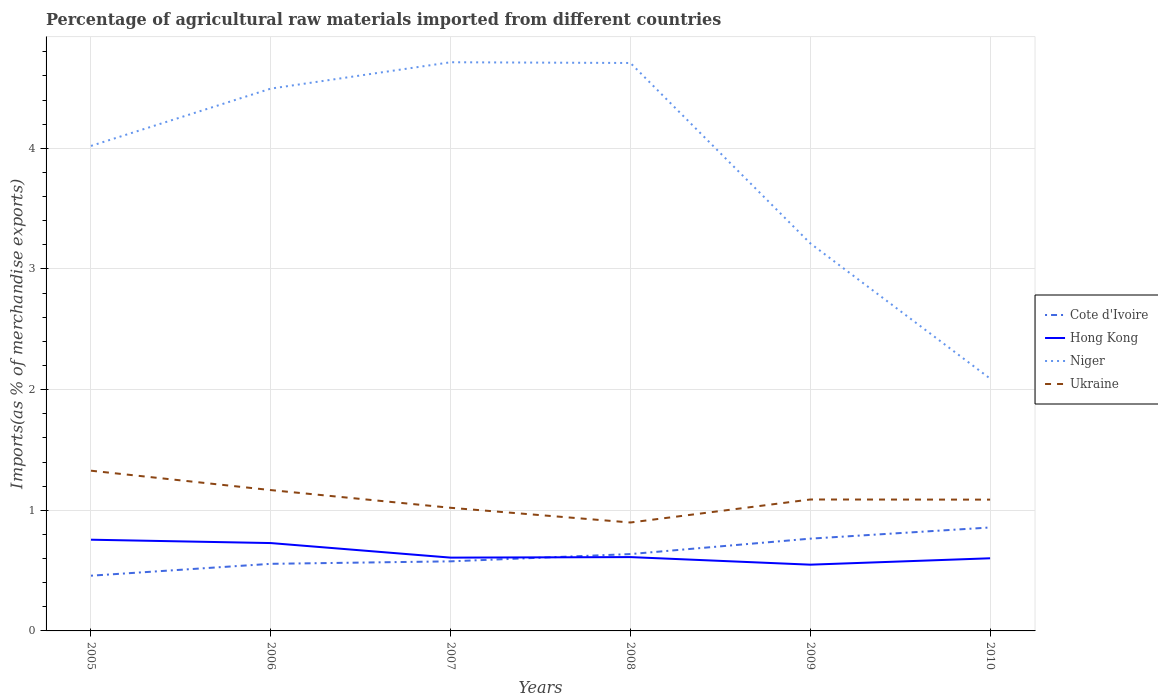Across all years, what is the maximum percentage of imports to different countries in Hong Kong?
Provide a succinct answer. 0.55. What is the total percentage of imports to different countries in Niger in the graph?
Provide a succinct answer. 1.5. What is the difference between the highest and the second highest percentage of imports to different countries in Niger?
Keep it short and to the point. 2.62. What is the difference between the highest and the lowest percentage of imports to different countries in Hong Kong?
Offer a terse response. 2. Is the percentage of imports to different countries in Niger strictly greater than the percentage of imports to different countries in Cote d'Ivoire over the years?
Your answer should be compact. No. How many lines are there?
Give a very brief answer. 4. Does the graph contain any zero values?
Provide a succinct answer. No. Does the graph contain grids?
Make the answer very short. Yes. How many legend labels are there?
Offer a terse response. 4. What is the title of the graph?
Ensure brevity in your answer.  Percentage of agricultural raw materials imported from different countries. Does "Haiti" appear as one of the legend labels in the graph?
Ensure brevity in your answer.  No. What is the label or title of the X-axis?
Your answer should be compact. Years. What is the label or title of the Y-axis?
Your answer should be compact. Imports(as % of merchandise exports). What is the Imports(as % of merchandise exports) of Cote d'Ivoire in 2005?
Offer a terse response. 0.46. What is the Imports(as % of merchandise exports) in Hong Kong in 2005?
Your answer should be compact. 0.76. What is the Imports(as % of merchandise exports) in Niger in 2005?
Your answer should be very brief. 4.02. What is the Imports(as % of merchandise exports) of Ukraine in 2005?
Offer a terse response. 1.33. What is the Imports(as % of merchandise exports) of Cote d'Ivoire in 2006?
Provide a short and direct response. 0.56. What is the Imports(as % of merchandise exports) of Hong Kong in 2006?
Provide a succinct answer. 0.73. What is the Imports(as % of merchandise exports) of Niger in 2006?
Keep it short and to the point. 4.49. What is the Imports(as % of merchandise exports) of Ukraine in 2006?
Offer a terse response. 1.17. What is the Imports(as % of merchandise exports) in Cote d'Ivoire in 2007?
Your answer should be very brief. 0.58. What is the Imports(as % of merchandise exports) in Hong Kong in 2007?
Your answer should be very brief. 0.61. What is the Imports(as % of merchandise exports) in Niger in 2007?
Make the answer very short. 4.71. What is the Imports(as % of merchandise exports) in Ukraine in 2007?
Offer a terse response. 1.02. What is the Imports(as % of merchandise exports) in Cote d'Ivoire in 2008?
Your answer should be compact. 0.64. What is the Imports(as % of merchandise exports) in Hong Kong in 2008?
Ensure brevity in your answer.  0.61. What is the Imports(as % of merchandise exports) of Niger in 2008?
Keep it short and to the point. 4.71. What is the Imports(as % of merchandise exports) of Ukraine in 2008?
Your response must be concise. 0.9. What is the Imports(as % of merchandise exports) of Cote d'Ivoire in 2009?
Your answer should be compact. 0.76. What is the Imports(as % of merchandise exports) of Hong Kong in 2009?
Ensure brevity in your answer.  0.55. What is the Imports(as % of merchandise exports) of Niger in 2009?
Keep it short and to the point. 3.21. What is the Imports(as % of merchandise exports) in Ukraine in 2009?
Your response must be concise. 1.09. What is the Imports(as % of merchandise exports) in Cote d'Ivoire in 2010?
Offer a very short reply. 0.86. What is the Imports(as % of merchandise exports) in Hong Kong in 2010?
Your response must be concise. 0.6. What is the Imports(as % of merchandise exports) of Niger in 2010?
Provide a succinct answer. 2.09. What is the Imports(as % of merchandise exports) in Ukraine in 2010?
Make the answer very short. 1.09. Across all years, what is the maximum Imports(as % of merchandise exports) of Cote d'Ivoire?
Ensure brevity in your answer.  0.86. Across all years, what is the maximum Imports(as % of merchandise exports) of Hong Kong?
Your answer should be compact. 0.76. Across all years, what is the maximum Imports(as % of merchandise exports) of Niger?
Ensure brevity in your answer.  4.71. Across all years, what is the maximum Imports(as % of merchandise exports) of Ukraine?
Provide a succinct answer. 1.33. Across all years, what is the minimum Imports(as % of merchandise exports) of Cote d'Ivoire?
Your answer should be very brief. 0.46. Across all years, what is the minimum Imports(as % of merchandise exports) of Hong Kong?
Keep it short and to the point. 0.55. Across all years, what is the minimum Imports(as % of merchandise exports) in Niger?
Offer a terse response. 2.09. Across all years, what is the minimum Imports(as % of merchandise exports) of Ukraine?
Provide a short and direct response. 0.9. What is the total Imports(as % of merchandise exports) in Cote d'Ivoire in the graph?
Make the answer very short. 3.85. What is the total Imports(as % of merchandise exports) in Hong Kong in the graph?
Keep it short and to the point. 3.85. What is the total Imports(as % of merchandise exports) of Niger in the graph?
Offer a very short reply. 23.24. What is the total Imports(as % of merchandise exports) in Ukraine in the graph?
Your answer should be very brief. 6.59. What is the difference between the Imports(as % of merchandise exports) in Cote d'Ivoire in 2005 and that in 2006?
Your answer should be very brief. -0.1. What is the difference between the Imports(as % of merchandise exports) of Hong Kong in 2005 and that in 2006?
Offer a very short reply. 0.03. What is the difference between the Imports(as % of merchandise exports) of Niger in 2005 and that in 2006?
Your answer should be compact. -0.47. What is the difference between the Imports(as % of merchandise exports) of Ukraine in 2005 and that in 2006?
Your answer should be compact. 0.16. What is the difference between the Imports(as % of merchandise exports) in Cote d'Ivoire in 2005 and that in 2007?
Make the answer very short. -0.12. What is the difference between the Imports(as % of merchandise exports) in Hong Kong in 2005 and that in 2007?
Your answer should be very brief. 0.15. What is the difference between the Imports(as % of merchandise exports) of Niger in 2005 and that in 2007?
Ensure brevity in your answer.  -0.69. What is the difference between the Imports(as % of merchandise exports) of Ukraine in 2005 and that in 2007?
Your answer should be very brief. 0.31. What is the difference between the Imports(as % of merchandise exports) in Cote d'Ivoire in 2005 and that in 2008?
Provide a succinct answer. -0.18. What is the difference between the Imports(as % of merchandise exports) of Hong Kong in 2005 and that in 2008?
Your response must be concise. 0.14. What is the difference between the Imports(as % of merchandise exports) in Niger in 2005 and that in 2008?
Ensure brevity in your answer.  -0.69. What is the difference between the Imports(as % of merchandise exports) in Ukraine in 2005 and that in 2008?
Keep it short and to the point. 0.43. What is the difference between the Imports(as % of merchandise exports) of Cote d'Ivoire in 2005 and that in 2009?
Give a very brief answer. -0.31. What is the difference between the Imports(as % of merchandise exports) in Hong Kong in 2005 and that in 2009?
Make the answer very short. 0.21. What is the difference between the Imports(as % of merchandise exports) of Niger in 2005 and that in 2009?
Ensure brevity in your answer.  0.81. What is the difference between the Imports(as % of merchandise exports) in Ukraine in 2005 and that in 2009?
Offer a terse response. 0.24. What is the difference between the Imports(as % of merchandise exports) of Cote d'Ivoire in 2005 and that in 2010?
Provide a succinct answer. -0.4. What is the difference between the Imports(as % of merchandise exports) in Hong Kong in 2005 and that in 2010?
Ensure brevity in your answer.  0.15. What is the difference between the Imports(as % of merchandise exports) in Niger in 2005 and that in 2010?
Keep it short and to the point. 1.93. What is the difference between the Imports(as % of merchandise exports) in Ukraine in 2005 and that in 2010?
Give a very brief answer. 0.24. What is the difference between the Imports(as % of merchandise exports) in Cote d'Ivoire in 2006 and that in 2007?
Give a very brief answer. -0.02. What is the difference between the Imports(as % of merchandise exports) of Hong Kong in 2006 and that in 2007?
Offer a terse response. 0.12. What is the difference between the Imports(as % of merchandise exports) in Niger in 2006 and that in 2007?
Ensure brevity in your answer.  -0.22. What is the difference between the Imports(as % of merchandise exports) of Ukraine in 2006 and that in 2007?
Your response must be concise. 0.15. What is the difference between the Imports(as % of merchandise exports) of Cote d'Ivoire in 2006 and that in 2008?
Offer a very short reply. -0.08. What is the difference between the Imports(as % of merchandise exports) in Hong Kong in 2006 and that in 2008?
Provide a succinct answer. 0.12. What is the difference between the Imports(as % of merchandise exports) of Niger in 2006 and that in 2008?
Offer a very short reply. -0.21. What is the difference between the Imports(as % of merchandise exports) of Ukraine in 2006 and that in 2008?
Your answer should be compact. 0.27. What is the difference between the Imports(as % of merchandise exports) of Cote d'Ivoire in 2006 and that in 2009?
Make the answer very short. -0.21. What is the difference between the Imports(as % of merchandise exports) of Hong Kong in 2006 and that in 2009?
Keep it short and to the point. 0.18. What is the difference between the Imports(as % of merchandise exports) in Niger in 2006 and that in 2009?
Offer a terse response. 1.28. What is the difference between the Imports(as % of merchandise exports) in Ukraine in 2006 and that in 2009?
Keep it short and to the point. 0.08. What is the difference between the Imports(as % of merchandise exports) of Cote d'Ivoire in 2006 and that in 2010?
Your response must be concise. -0.3. What is the difference between the Imports(as % of merchandise exports) of Hong Kong in 2006 and that in 2010?
Make the answer very short. 0.13. What is the difference between the Imports(as % of merchandise exports) of Niger in 2006 and that in 2010?
Your answer should be very brief. 2.4. What is the difference between the Imports(as % of merchandise exports) in Ukraine in 2006 and that in 2010?
Make the answer very short. 0.08. What is the difference between the Imports(as % of merchandise exports) in Cote d'Ivoire in 2007 and that in 2008?
Your response must be concise. -0.06. What is the difference between the Imports(as % of merchandise exports) of Hong Kong in 2007 and that in 2008?
Your answer should be compact. -0. What is the difference between the Imports(as % of merchandise exports) in Niger in 2007 and that in 2008?
Give a very brief answer. 0.01. What is the difference between the Imports(as % of merchandise exports) in Ukraine in 2007 and that in 2008?
Ensure brevity in your answer.  0.12. What is the difference between the Imports(as % of merchandise exports) in Cote d'Ivoire in 2007 and that in 2009?
Your response must be concise. -0.19. What is the difference between the Imports(as % of merchandise exports) of Hong Kong in 2007 and that in 2009?
Provide a succinct answer. 0.06. What is the difference between the Imports(as % of merchandise exports) of Niger in 2007 and that in 2009?
Your answer should be very brief. 1.5. What is the difference between the Imports(as % of merchandise exports) in Ukraine in 2007 and that in 2009?
Your response must be concise. -0.07. What is the difference between the Imports(as % of merchandise exports) in Cote d'Ivoire in 2007 and that in 2010?
Make the answer very short. -0.28. What is the difference between the Imports(as % of merchandise exports) in Hong Kong in 2007 and that in 2010?
Offer a very short reply. 0.01. What is the difference between the Imports(as % of merchandise exports) in Niger in 2007 and that in 2010?
Ensure brevity in your answer.  2.62. What is the difference between the Imports(as % of merchandise exports) of Ukraine in 2007 and that in 2010?
Your response must be concise. -0.07. What is the difference between the Imports(as % of merchandise exports) of Cote d'Ivoire in 2008 and that in 2009?
Your response must be concise. -0.13. What is the difference between the Imports(as % of merchandise exports) of Hong Kong in 2008 and that in 2009?
Provide a short and direct response. 0.06. What is the difference between the Imports(as % of merchandise exports) of Niger in 2008 and that in 2009?
Ensure brevity in your answer.  1.49. What is the difference between the Imports(as % of merchandise exports) in Ukraine in 2008 and that in 2009?
Ensure brevity in your answer.  -0.19. What is the difference between the Imports(as % of merchandise exports) of Cote d'Ivoire in 2008 and that in 2010?
Offer a terse response. -0.22. What is the difference between the Imports(as % of merchandise exports) of Hong Kong in 2008 and that in 2010?
Provide a short and direct response. 0.01. What is the difference between the Imports(as % of merchandise exports) of Niger in 2008 and that in 2010?
Your response must be concise. 2.62. What is the difference between the Imports(as % of merchandise exports) in Ukraine in 2008 and that in 2010?
Your answer should be compact. -0.19. What is the difference between the Imports(as % of merchandise exports) of Cote d'Ivoire in 2009 and that in 2010?
Ensure brevity in your answer.  -0.09. What is the difference between the Imports(as % of merchandise exports) in Hong Kong in 2009 and that in 2010?
Give a very brief answer. -0.05. What is the difference between the Imports(as % of merchandise exports) of Niger in 2009 and that in 2010?
Give a very brief answer. 1.12. What is the difference between the Imports(as % of merchandise exports) in Ukraine in 2009 and that in 2010?
Offer a terse response. 0. What is the difference between the Imports(as % of merchandise exports) in Cote d'Ivoire in 2005 and the Imports(as % of merchandise exports) in Hong Kong in 2006?
Provide a short and direct response. -0.27. What is the difference between the Imports(as % of merchandise exports) in Cote d'Ivoire in 2005 and the Imports(as % of merchandise exports) in Niger in 2006?
Offer a terse response. -4.04. What is the difference between the Imports(as % of merchandise exports) of Cote d'Ivoire in 2005 and the Imports(as % of merchandise exports) of Ukraine in 2006?
Your response must be concise. -0.71. What is the difference between the Imports(as % of merchandise exports) in Hong Kong in 2005 and the Imports(as % of merchandise exports) in Niger in 2006?
Keep it short and to the point. -3.74. What is the difference between the Imports(as % of merchandise exports) in Hong Kong in 2005 and the Imports(as % of merchandise exports) in Ukraine in 2006?
Your answer should be compact. -0.41. What is the difference between the Imports(as % of merchandise exports) of Niger in 2005 and the Imports(as % of merchandise exports) of Ukraine in 2006?
Your answer should be very brief. 2.85. What is the difference between the Imports(as % of merchandise exports) in Cote d'Ivoire in 2005 and the Imports(as % of merchandise exports) in Hong Kong in 2007?
Your answer should be very brief. -0.15. What is the difference between the Imports(as % of merchandise exports) in Cote d'Ivoire in 2005 and the Imports(as % of merchandise exports) in Niger in 2007?
Your response must be concise. -4.26. What is the difference between the Imports(as % of merchandise exports) of Cote d'Ivoire in 2005 and the Imports(as % of merchandise exports) of Ukraine in 2007?
Ensure brevity in your answer.  -0.56. What is the difference between the Imports(as % of merchandise exports) in Hong Kong in 2005 and the Imports(as % of merchandise exports) in Niger in 2007?
Your answer should be compact. -3.96. What is the difference between the Imports(as % of merchandise exports) of Hong Kong in 2005 and the Imports(as % of merchandise exports) of Ukraine in 2007?
Offer a terse response. -0.26. What is the difference between the Imports(as % of merchandise exports) in Niger in 2005 and the Imports(as % of merchandise exports) in Ukraine in 2007?
Ensure brevity in your answer.  3. What is the difference between the Imports(as % of merchandise exports) of Cote d'Ivoire in 2005 and the Imports(as % of merchandise exports) of Hong Kong in 2008?
Provide a short and direct response. -0.15. What is the difference between the Imports(as % of merchandise exports) in Cote d'Ivoire in 2005 and the Imports(as % of merchandise exports) in Niger in 2008?
Your answer should be compact. -4.25. What is the difference between the Imports(as % of merchandise exports) in Cote d'Ivoire in 2005 and the Imports(as % of merchandise exports) in Ukraine in 2008?
Ensure brevity in your answer.  -0.44. What is the difference between the Imports(as % of merchandise exports) in Hong Kong in 2005 and the Imports(as % of merchandise exports) in Niger in 2008?
Provide a short and direct response. -3.95. What is the difference between the Imports(as % of merchandise exports) in Hong Kong in 2005 and the Imports(as % of merchandise exports) in Ukraine in 2008?
Offer a very short reply. -0.14. What is the difference between the Imports(as % of merchandise exports) in Niger in 2005 and the Imports(as % of merchandise exports) in Ukraine in 2008?
Make the answer very short. 3.12. What is the difference between the Imports(as % of merchandise exports) of Cote d'Ivoire in 2005 and the Imports(as % of merchandise exports) of Hong Kong in 2009?
Ensure brevity in your answer.  -0.09. What is the difference between the Imports(as % of merchandise exports) in Cote d'Ivoire in 2005 and the Imports(as % of merchandise exports) in Niger in 2009?
Make the answer very short. -2.75. What is the difference between the Imports(as % of merchandise exports) of Cote d'Ivoire in 2005 and the Imports(as % of merchandise exports) of Ukraine in 2009?
Provide a short and direct response. -0.63. What is the difference between the Imports(as % of merchandise exports) in Hong Kong in 2005 and the Imports(as % of merchandise exports) in Niger in 2009?
Give a very brief answer. -2.46. What is the difference between the Imports(as % of merchandise exports) of Hong Kong in 2005 and the Imports(as % of merchandise exports) of Ukraine in 2009?
Make the answer very short. -0.33. What is the difference between the Imports(as % of merchandise exports) of Niger in 2005 and the Imports(as % of merchandise exports) of Ukraine in 2009?
Give a very brief answer. 2.93. What is the difference between the Imports(as % of merchandise exports) in Cote d'Ivoire in 2005 and the Imports(as % of merchandise exports) in Hong Kong in 2010?
Offer a very short reply. -0.14. What is the difference between the Imports(as % of merchandise exports) of Cote d'Ivoire in 2005 and the Imports(as % of merchandise exports) of Niger in 2010?
Your answer should be compact. -1.63. What is the difference between the Imports(as % of merchandise exports) of Cote d'Ivoire in 2005 and the Imports(as % of merchandise exports) of Ukraine in 2010?
Your answer should be compact. -0.63. What is the difference between the Imports(as % of merchandise exports) in Hong Kong in 2005 and the Imports(as % of merchandise exports) in Niger in 2010?
Offer a very short reply. -1.34. What is the difference between the Imports(as % of merchandise exports) in Hong Kong in 2005 and the Imports(as % of merchandise exports) in Ukraine in 2010?
Keep it short and to the point. -0.33. What is the difference between the Imports(as % of merchandise exports) of Niger in 2005 and the Imports(as % of merchandise exports) of Ukraine in 2010?
Make the answer very short. 2.93. What is the difference between the Imports(as % of merchandise exports) in Cote d'Ivoire in 2006 and the Imports(as % of merchandise exports) in Hong Kong in 2007?
Offer a very short reply. -0.05. What is the difference between the Imports(as % of merchandise exports) of Cote d'Ivoire in 2006 and the Imports(as % of merchandise exports) of Niger in 2007?
Provide a short and direct response. -4.16. What is the difference between the Imports(as % of merchandise exports) of Cote d'Ivoire in 2006 and the Imports(as % of merchandise exports) of Ukraine in 2007?
Offer a terse response. -0.46. What is the difference between the Imports(as % of merchandise exports) in Hong Kong in 2006 and the Imports(as % of merchandise exports) in Niger in 2007?
Your answer should be compact. -3.99. What is the difference between the Imports(as % of merchandise exports) of Hong Kong in 2006 and the Imports(as % of merchandise exports) of Ukraine in 2007?
Your answer should be very brief. -0.29. What is the difference between the Imports(as % of merchandise exports) in Niger in 2006 and the Imports(as % of merchandise exports) in Ukraine in 2007?
Keep it short and to the point. 3.47. What is the difference between the Imports(as % of merchandise exports) in Cote d'Ivoire in 2006 and the Imports(as % of merchandise exports) in Hong Kong in 2008?
Your response must be concise. -0.06. What is the difference between the Imports(as % of merchandise exports) in Cote d'Ivoire in 2006 and the Imports(as % of merchandise exports) in Niger in 2008?
Offer a terse response. -4.15. What is the difference between the Imports(as % of merchandise exports) in Cote d'Ivoire in 2006 and the Imports(as % of merchandise exports) in Ukraine in 2008?
Your answer should be compact. -0.34. What is the difference between the Imports(as % of merchandise exports) in Hong Kong in 2006 and the Imports(as % of merchandise exports) in Niger in 2008?
Give a very brief answer. -3.98. What is the difference between the Imports(as % of merchandise exports) in Hong Kong in 2006 and the Imports(as % of merchandise exports) in Ukraine in 2008?
Your answer should be compact. -0.17. What is the difference between the Imports(as % of merchandise exports) of Niger in 2006 and the Imports(as % of merchandise exports) of Ukraine in 2008?
Your response must be concise. 3.6. What is the difference between the Imports(as % of merchandise exports) in Cote d'Ivoire in 2006 and the Imports(as % of merchandise exports) in Hong Kong in 2009?
Your response must be concise. 0.01. What is the difference between the Imports(as % of merchandise exports) of Cote d'Ivoire in 2006 and the Imports(as % of merchandise exports) of Niger in 2009?
Your answer should be compact. -2.66. What is the difference between the Imports(as % of merchandise exports) in Cote d'Ivoire in 2006 and the Imports(as % of merchandise exports) in Ukraine in 2009?
Keep it short and to the point. -0.53. What is the difference between the Imports(as % of merchandise exports) of Hong Kong in 2006 and the Imports(as % of merchandise exports) of Niger in 2009?
Your answer should be very brief. -2.48. What is the difference between the Imports(as % of merchandise exports) in Hong Kong in 2006 and the Imports(as % of merchandise exports) in Ukraine in 2009?
Offer a very short reply. -0.36. What is the difference between the Imports(as % of merchandise exports) in Niger in 2006 and the Imports(as % of merchandise exports) in Ukraine in 2009?
Keep it short and to the point. 3.41. What is the difference between the Imports(as % of merchandise exports) in Cote d'Ivoire in 2006 and the Imports(as % of merchandise exports) in Hong Kong in 2010?
Offer a very short reply. -0.05. What is the difference between the Imports(as % of merchandise exports) of Cote d'Ivoire in 2006 and the Imports(as % of merchandise exports) of Niger in 2010?
Offer a terse response. -1.54. What is the difference between the Imports(as % of merchandise exports) in Cote d'Ivoire in 2006 and the Imports(as % of merchandise exports) in Ukraine in 2010?
Your answer should be very brief. -0.53. What is the difference between the Imports(as % of merchandise exports) in Hong Kong in 2006 and the Imports(as % of merchandise exports) in Niger in 2010?
Your answer should be compact. -1.36. What is the difference between the Imports(as % of merchandise exports) of Hong Kong in 2006 and the Imports(as % of merchandise exports) of Ukraine in 2010?
Your answer should be very brief. -0.36. What is the difference between the Imports(as % of merchandise exports) of Niger in 2006 and the Imports(as % of merchandise exports) of Ukraine in 2010?
Your answer should be very brief. 3.41. What is the difference between the Imports(as % of merchandise exports) of Cote d'Ivoire in 2007 and the Imports(as % of merchandise exports) of Hong Kong in 2008?
Keep it short and to the point. -0.04. What is the difference between the Imports(as % of merchandise exports) in Cote d'Ivoire in 2007 and the Imports(as % of merchandise exports) in Niger in 2008?
Your answer should be very brief. -4.13. What is the difference between the Imports(as % of merchandise exports) in Cote d'Ivoire in 2007 and the Imports(as % of merchandise exports) in Ukraine in 2008?
Your answer should be very brief. -0.32. What is the difference between the Imports(as % of merchandise exports) of Hong Kong in 2007 and the Imports(as % of merchandise exports) of Niger in 2008?
Your answer should be compact. -4.1. What is the difference between the Imports(as % of merchandise exports) in Hong Kong in 2007 and the Imports(as % of merchandise exports) in Ukraine in 2008?
Provide a short and direct response. -0.29. What is the difference between the Imports(as % of merchandise exports) of Niger in 2007 and the Imports(as % of merchandise exports) of Ukraine in 2008?
Provide a short and direct response. 3.81. What is the difference between the Imports(as % of merchandise exports) in Cote d'Ivoire in 2007 and the Imports(as % of merchandise exports) in Hong Kong in 2009?
Offer a terse response. 0.03. What is the difference between the Imports(as % of merchandise exports) of Cote d'Ivoire in 2007 and the Imports(as % of merchandise exports) of Niger in 2009?
Make the answer very short. -2.64. What is the difference between the Imports(as % of merchandise exports) in Cote d'Ivoire in 2007 and the Imports(as % of merchandise exports) in Ukraine in 2009?
Provide a short and direct response. -0.51. What is the difference between the Imports(as % of merchandise exports) in Hong Kong in 2007 and the Imports(as % of merchandise exports) in Niger in 2009?
Ensure brevity in your answer.  -2.6. What is the difference between the Imports(as % of merchandise exports) of Hong Kong in 2007 and the Imports(as % of merchandise exports) of Ukraine in 2009?
Your response must be concise. -0.48. What is the difference between the Imports(as % of merchandise exports) in Niger in 2007 and the Imports(as % of merchandise exports) in Ukraine in 2009?
Your response must be concise. 3.62. What is the difference between the Imports(as % of merchandise exports) in Cote d'Ivoire in 2007 and the Imports(as % of merchandise exports) in Hong Kong in 2010?
Keep it short and to the point. -0.03. What is the difference between the Imports(as % of merchandise exports) in Cote d'Ivoire in 2007 and the Imports(as % of merchandise exports) in Niger in 2010?
Ensure brevity in your answer.  -1.51. What is the difference between the Imports(as % of merchandise exports) of Cote d'Ivoire in 2007 and the Imports(as % of merchandise exports) of Ukraine in 2010?
Make the answer very short. -0.51. What is the difference between the Imports(as % of merchandise exports) in Hong Kong in 2007 and the Imports(as % of merchandise exports) in Niger in 2010?
Offer a very short reply. -1.48. What is the difference between the Imports(as % of merchandise exports) of Hong Kong in 2007 and the Imports(as % of merchandise exports) of Ukraine in 2010?
Your answer should be very brief. -0.48. What is the difference between the Imports(as % of merchandise exports) of Niger in 2007 and the Imports(as % of merchandise exports) of Ukraine in 2010?
Make the answer very short. 3.62. What is the difference between the Imports(as % of merchandise exports) in Cote d'Ivoire in 2008 and the Imports(as % of merchandise exports) in Hong Kong in 2009?
Provide a succinct answer. 0.09. What is the difference between the Imports(as % of merchandise exports) of Cote d'Ivoire in 2008 and the Imports(as % of merchandise exports) of Niger in 2009?
Provide a short and direct response. -2.58. What is the difference between the Imports(as % of merchandise exports) of Cote d'Ivoire in 2008 and the Imports(as % of merchandise exports) of Ukraine in 2009?
Provide a succinct answer. -0.45. What is the difference between the Imports(as % of merchandise exports) of Hong Kong in 2008 and the Imports(as % of merchandise exports) of Niger in 2009?
Give a very brief answer. -2.6. What is the difference between the Imports(as % of merchandise exports) of Hong Kong in 2008 and the Imports(as % of merchandise exports) of Ukraine in 2009?
Provide a short and direct response. -0.48. What is the difference between the Imports(as % of merchandise exports) of Niger in 2008 and the Imports(as % of merchandise exports) of Ukraine in 2009?
Give a very brief answer. 3.62. What is the difference between the Imports(as % of merchandise exports) of Cote d'Ivoire in 2008 and the Imports(as % of merchandise exports) of Hong Kong in 2010?
Provide a short and direct response. 0.03. What is the difference between the Imports(as % of merchandise exports) of Cote d'Ivoire in 2008 and the Imports(as % of merchandise exports) of Niger in 2010?
Your answer should be very brief. -1.45. What is the difference between the Imports(as % of merchandise exports) in Cote d'Ivoire in 2008 and the Imports(as % of merchandise exports) in Ukraine in 2010?
Keep it short and to the point. -0.45. What is the difference between the Imports(as % of merchandise exports) in Hong Kong in 2008 and the Imports(as % of merchandise exports) in Niger in 2010?
Offer a very short reply. -1.48. What is the difference between the Imports(as % of merchandise exports) of Hong Kong in 2008 and the Imports(as % of merchandise exports) of Ukraine in 2010?
Ensure brevity in your answer.  -0.48. What is the difference between the Imports(as % of merchandise exports) in Niger in 2008 and the Imports(as % of merchandise exports) in Ukraine in 2010?
Give a very brief answer. 3.62. What is the difference between the Imports(as % of merchandise exports) of Cote d'Ivoire in 2009 and the Imports(as % of merchandise exports) of Hong Kong in 2010?
Your answer should be very brief. 0.16. What is the difference between the Imports(as % of merchandise exports) of Cote d'Ivoire in 2009 and the Imports(as % of merchandise exports) of Niger in 2010?
Your response must be concise. -1.33. What is the difference between the Imports(as % of merchandise exports) of Cote d'Ivoire in 2009 and the Imports(as % of merchandise exports) of Ukraine in 2010?
Make the answer very short. -0.32. What is the difference between the Imports(as % of merchandise exports) in Hong Kong in 2009 and the Imports(as % of merchandise exports) in Niger in 2010?
Keep it short and to the point. -1.54. What is the difference between the Imports(as % of merchandise exports) in Hong Kong in 2009 and the Imports(as % of merchandise exports) in Ukraine in 2010?
Your answer should be compact. -0.54. What is the difference between the Imports(as % of merchandise exports) in Niger in 2009 and the Imports(as % of merchandise exports) in Ukraine in 2010?
Give a very brief answer. 2.12. What is the average Imports(as % of merchandise exports) in Cote d'Ivoire per year?
Keep it short and to the point. 0.64. What is the average Imports(as % of merchandise exports) of Hong Kong per year?
Make the answer very short. 0.64. What is the average Imports(as % of merchandise exports) of Niger per year?
Your answer should be very brief. 3.87. What is the average Imports(as % of merchandise exports) of Ukraine per year?
Your answer should be very brief. 1.1. In the year 2005, what is the difference between the Imports(as % of merchandise exports) in Cote d'Ivoire and Imports(as % of merchandise exports) in Hong Kong?
Ensure brevity in your answer.  -0.3. In the year 2005, what is the difference between the Imports(as % of merchandise exports) in Cote d'Ivoire and Imports(as % of merchandise exports) in Niger?
Provide a short and direct response. -3.56. In the year 2005, what is the difference between the Imports(as % of merchandise exports) of Cote d'Ivoire and Imports(as % of merchandise exports) of Ukraine?
Ensure brevity in your answer.  -0.87. In the year 2005, what is the difference between the Imports(as % of merchandise exports) of Hong Kong and Imports(as % of merchandise exports) of Niger?
Ensure brevity in your answer.  -3.26. In the year 2005, what is the difference between the Imports(as % of merchandise exports) of Hong Kong and Imports(as % of merchandise exports) of Ukraine?
Ensure brevity in your answer.  -0.57. In the year 2005, what is the difference between the Imports(as % of merchandise exports) in Niger and Imports(as % of merchandise exports) in Ukraine?
Make the answer very short. 2.69. In the year 2006, what is the difference between the Imports(as % of merchandise exports) in Cote d'Ivoire and Imports(as % of merchandise exports) in Hong Kong?
Provide a short and direct response. -0.17. In the year 2006, what is the difference between the Imports(as % of merchandise exports) of Cote d'Ivoire and Imports(as % of merchandise exports) of Niger?
Provide a succinct answer. -3.94. In the year 2006, what is the difference between the Imports(as % of merchandise exports) of Cote d'Ivoire and Imports(as % of merchandise exports) of Ukraine?
Give a very brief answer. -0.61. In the year 2006, what is the difference between the Imports(as % of merchandise exports) in Hong Kong and Imports(as % of merchandise exports) in Niger?
Make the answer very short. -3.77. In the year 2006, what is the difference between the Imports(as % of merchandise exports) of Hong Kong and Imports(as % of merchandise exports) of Ukraine?
Ensure brevity in your answer.  -0.44. In the year 2006, what is the difference between the Imports(as % of merchandise exports) of Niger and Imports(as % of merchandise exports) of Ukraine?
Your response must be concise. 3.33. In the year 2007, what is the difference between the Imports(as % of merchandise exports) of Cote d'Ivoire and Imports(as % of merchandise exports) of Hong Kong?
Offer a very short reply. -0.03. In the year 2007, what is the difference between the Imports(as % of merchandise exports) in Cote d'Ivoire and Imports(as % of merchandise exports) in Niger?
Offer a terse response. -4.14. In the year 2007, what is the difference between the Imports(as % of merchandise exports) in Cote d'Ivoire and Imports(as % of merchandise exports) in Ukraine?
Provide a succinct answer. -0.44. In the year 2007, what is the difference between the Imports(as % of merchandise exports) in Hong Kong and Imports(as % of merchandise exports) in Niger?
Your answer should be very brief. -4.11. In the year 2007, what is the difference between the Imports(as % of merchandise exports) of Hong Kong and Imports(as % of merchandise exports) of Ukraine?
Ensure brevity in your answer.  -0.41. In the year 2007, what is the difference between the Imports(as % of merchandise exports) of Niger and Imports(as % of merchandise exports) of Ukraine?
Make the answer very short. 3.69. In the year 2008, what is the difference between the Imports(as % of merchandise exports) in Cote d'Ivoire and Imports(as % of merchandise exports) in Hong Kong?
Make the answer very short. 0.03. In the year 2008, what is the difference between the Imports(as % of merchandise exports) in Cote d'Ivoire and Imports(as % of merchandise exports) in Niger?
Keep it short and to the point. -4.07. In the year 2008, what is the difference between the Imports(as % of merchandise exports) of Cote d'Ivoire and Imports(as % of merchandise exports) of Ukraine?
Provide a short and direct response. -0.26. In the year 2008, what is the difference between the Imports(as % of merchandise exports) in Hong Kong and Imports(as % of merchandise exports) in Niger?
Offer a terse response. -4.1. In the year 2008, what is the difference between the Imports(as % of merchandise exports) in Hong Kong and Imports(as % of merchandise exports) in Ukraine?
Provide a short and direct response. -0.29. In the year 2008, what is the difference between the Imports(as % of merchandise exports) of Niger and Imports(as % of merchandise exports) of Ukraine?
Make the answer very short. 3.81. In the year 2009, what is the difference between the Imports(as % of merchandise exports) of Cote d'Ivoire and Imports(as % of merchandise exports) of Hong Kong?
Provide a short and direct response. 0.22. In the year 2009, what is the difference between the Imports(as % of merchandise exports) in Cote d'Ivoire and Imports(as % of merchandise exports) in Niger?
Ensure brevity in your answer.  -2.45. In the year 2009, what is the difference between the Imports(as % of merchandise exports) in Cote d'Ivoire and Imports(as % of merchandise exports) in Ukraine?
Offer a terse response. -0.32. In the year 2009, what is the difference between the Imports(as % of merchandise exports) of Hong Kong and Imports(as % of merchandise exports) of Niger?
Provide a short and direct response. -2.66. In the year 2009, what is the difference between the Imports(as % of merchandise exports) of Hong Kong and Imports(as % of merchandise exports) of Ukraine?
Offer a very short reply. -0.54. In the year 2009, what is the difference between the Imports(as % of merchandise exports) in Niger and Imports(as % of merchandise exports) in Ukraine?
Your response must be concise. 2.12. In the year 2010, what is the difference between the Imports(as % of merchandise exports) in Cote d'Ivoire and Imports(as % of merchandise exports) in Hong Kong?
Give a very brief answer. 0.26. In the year 2010, what is the difference between the Imports(as % of merchandise exports) in Cote d'Ivoire and Imports(as % of merchandise exports) in Niger?
Give a very brief answer. -1.23. In the year 2010, what is the difference between the Imports(as % of merchandise exports) in Cote d'Ivoire and Imports(as % of merchandise exports) in Ukraine?
Your answer should be very brief. -0.23. In the year 2010, what is the difference between the Imports(as % of merchandise exports) of Hong Kong and Imports(as % of merchandise exports) of Niger?
Give a very brief answer. -1.49. In the year 2010, what is the difference between the Imports(as % of merchandise exports) in Hong Kong and Imports(as % of merchandise exports) in Ukraine?
Keep it short and to the point. -0.49. In the year 2010, what is the difference between the Imports(as % of merchandise exports) of Niger and Imports(as % of merchandise exports) of Ukraine?
Provide a short and direct response. 1. What is the ratio of the Imports(as % of merchandise exports) of Cote d'Ivoire in 2005 to that in 2006?
Your response must be concise. 0.82. What is the ratio of the Imports(as % of merchandise exports) of Hong Kong in 2005 to that in 2006?
Provide a short and direct response. 1.04. What is the ratio of the Imports(as % of merchandise exports) in Niger in 2005 to that in 2006?
Your answer should be compact. 0.89. What is the ratio of the Imports(as % of merchandise exports) in Ukraine in 2005 to that in 2006?
Keep it short and to the point. 1.14. What is the ratio of the Imports(as % of merchandise exports) of Cote d'Ivoire in 2005 to that in 2007?
Offer a terse response. 0.79. What is the ratio of the Imports(as % of merchandise exports) in Hong Kong in 2005 to that in 2007?
Keep it short and to the point. 1.24. What is the ratio of the Imports(as % of merchandise exports) of Niger in 2005 to that in 2007?
Give a very brief answer. 0.85. What is the ratio of the Imports(as % of merchandise exports) in Ukraine in 2005 to that in 2007?
Give a very brief answer. 1.3. What is the ratio of the Imports(as % of merchandise exports) of Cote d'Ivoire in 2005 to that in 2008?
Your response must be concise. 0.72. What is the ratio of the Imports(as % of merchandise exports) in Hong Kong in 2005 to that in 2008?
Your response must be concise. 1.24. What is the ratio of the Imports(as % of merchandise exports) in Niger in 2005 to that in 2008?
Provide a short and direct response. 0.85. What is the ratio of the Imports(as % of merchandise exports) in Ukraine in 2005 to that in 2008?
Make the answer very short. 1.48. What is the ratio of the Imports(as % of merchandise exports) in Cote d'Ivoire in 2005 to that in 2009?
Keep it short and to the point. 0.6. What is the ratio of the Imports(as % of merchandise exports) in Hong Kong in 2005 to that in 2009?
Your answer should be very brief. 1.38. What is the ratio of the Imports(as % of merchandise exports) of Niger in 2005 to that in 2009?
Provide a short and direct response. 1.25. What is the ratio of the Imports(as % of merchandise exports) of Ukraine in 2005 to that in 2009?
Offer a very short reply. 1.22. What is the ratio of the Imports(as % of merchandise exports) of Cote d'Ivoire in 2005 to that in 2010?
Offer a very short reply. 0.53. What is the ratio of the Imports(as % of merchandise exports) of Hong Kong in 2005 to that in 2010?
Make the answer very short. 1.26. What is the ratio of the Imports(as % of merchandise exports) in Niger in 2005 to that in 2010?
Provide a short and direct response. 1.92. What is the ratio of the Imports(as % of merchandise exports) of Ukraine in 2005 to that in 2010?
Ensure brevity in your answer.  1.22. What is the ratio of the Imports(as % of merchandise exports) of Cote d'Ivoire in 2006 to that in 2007?
Offer a terse response. 0.96. What is the ratio of the Imports(as % of merchandise exports) of Hong Kong in 2006 to that in 2007?
Offer a very short reply. 1.2. What is the ratio of the Imports(as % of merchandise exports) in Niger in 2006 to that in 2007?
Ensure brevity in your answer.  0.95. What is the ratio of the Imports(as % of merchandise exports) in Ukraine in 2006 to that in 2007?
Provide a succinct answer. 1.14. What is the ratio of the Imports(as % of merchandise exports) of Cote d'Ivoire in 2006 to that in 2008?
Your answer should be compact. 0.87. What is the ratio of the Imports(as % of merchandise exports) of Hong Kong in 2006 to that in 2008?
Your answer should be compact. 1.19. What is the ratio of the Imports(as % of merchandise exports) of Niger in 2006 to that in 2008?
Your answer should be very brief. 0.95. What is the ratio of the Imports(as % of merchandise exports) in Ukraine in 2006 to that in 2008?
Offer a terse response. 1.3. What is the ratio of the Imports(as % of merchandise exports) of Cote d'Ivoire in 2006 to that in 2009?
Give a very brief answer. 0.73. What is the ratio of the Imports(as % of merchandise exports) in Hong Kong in 2006 to that in 2009?
Provide a short and direct response. 1.33. What is the ratio of the Imports(as % of merchandise exports) in Niger in 2006 to that in 2009?
Make the answer very short. 1.4. What is the ratio of the Imports(as % of merchandise exports) of Ukraine in 2006 to that in 2009?
Provide a succinct answer. 1.07. What is the ratio of the Imports(as % of merchandise exports) in Cote d'Ivoire in 2006 to that in 2010?
Your response must be concise. 0.65. What is the ratio of the Imports(as % of merchandise exports) of Hong Kong in 2006 to that in 2010?
Offer a terse response. 1.21. What is the ratio of the Imports(as % of merchandise exports) of Niger in 2006 to that in 2010?
Provide a short and direct response. 2.15. What is the ratio of the Imports(as % of merchandise exports) in Ukraine in 2006 to that in 2010?
Keep it short and to the point. 1.07. What is the ratio of the Imports(as % of merchandise exports) in Cote d'Ivoire in 2007 to that in 2008?
Your answer should be compact. 0.91. What is the ratio of the Imports(as % of merchandise exports) of Hong Kong in 2007 to that in 2008?
Your answer should be compact. 0.99. What is the ratio of the Imports(as % of merchandise exports) of Ukraine in 2007 to that in 2008?
Keep it short and to the point. 1.14. What is the ratio of the Imports(as % of merchandise exports) in Cote d'Ivoire in 2007 to that in 2009?
Your response must be concise. 0.75. What is the ratio of the Imports(as % of merchandise exports) in Hong Kong in 2007 to that in 2009?
Provide a short and direct response. 1.11. What is the ratio of the Imports(as % of merchandise exports) of Niger in 2007 to that in 2009?
Your answer should be compact. 1.47. What is the ratio of the Imports(as % of merchandise exports) in Ukraine in 2007 to that in 2009?
Give a very brief answer. 0.94. What is the ratio of the Imports(as % of merchandise exports) of Cote d'Ivoire in 2007 to that in 2010?
Give a very brief answer. 0.67. What is the ratio of the Imports(as % of merchandise exports) of Hong Kong in 2007 to that in 2010?
Make the answer very short. 1.01. What is the ratio of the Imports(as % of merchandise exports) in Niger in 2007 to that in 2010?
Keep it short and to the point. 2.25. What is the ratio of the Imports(as % of merchandise exports) of Ukraine in 2007 to that in 2010?
Your answer should be compact. 0.94. What is the ratio of the Imports(as % of merchandise exports) in Cote d'Ivoire in 2008 to that in 2009?
Offer a very short reply. 0.83. What is the ratio of the Imports(as % of merchandise exports) of Hong Kong in 2008 to that in 2009?
Provide a short and direct response. 1.11. What is the ratio of the Imports(as % of merchandise exports) of Niger in 2008 to that in 2009?
Offer a terse response. 1.47. What is the ratio of the Imports(as % of merchandise exports) in Ukraine in 2008 to that in 2009?
Offer a very short reply. 0.82. What is the ratio of the Imports(as % of merchandise exports) in Cote d'Ivoire in 2008 to that in 2010?
Provide a succinct answer. 0.74. What is the ratio of the Imports(as % of merchandise exports) in Hong Kong in 2008 to that in 2010?
Provide a succinct answer. 1.02. What is the ratio of the Imports(as % of merchandise exports) of Niger in 2008 to that in 2010?
Make the answer very short. 2.25. What is the ratio of the Imports(as % of merchandise exports) in Ukraine in 2008 to that in 2010?
Ensure brevity in your answer.  0.83. What is the ratio of the Imports(as % of merchandise exports) of Cote d'Ivoire in 2009 to that in 2010?
Your answer should be very brief. 0.89. What is the ratio of the Imports(as % of merchandise exports) of Hong Kong in 2009 to that in 2010?
Offer a terse response. 0.91. What is the ratio of the Imports(as % of merchandise exports) in Niger in 2009 to that in 2010?
Offer a very short reply. 1.54. What is the difference between the highest and the second highest Imports(as % of merchandise exports) of Cote d'Ivoire?
Provide a short and direct response. 0.09. What is the difference between the highest and the second highest Imports(as % of merchandise exports) in Hong Kong?
Your answer should be compact. 0.03. What is the difference between the highest and the second highest Imports(as % of merchandise exports) of Niger?
Keep it short and to the point. 0.01. What is the difference between the highest and the second highest Imports(as % of merchandise exports) in Ukraine?
Provide a succinct answer. 0.16. What is the difference between the highest and the lowest Imports(as % of merchandise exports) of Cote d'Ivoire?
Provide a short and direct response. 0.4. What is the difference between the highest and the lowest Imports(as % of merchandise exports) in Hong Kong?
Provide a succinct answer. 0.21. What is the difference between the highest and the lowest Imports(as % of merchandise exports) of Niger?
Provide a succinct answer. 2.62. What is the difference between the highest and the lowest Imports(as % of merchandise exports) in Ukraine?
Give a very brief answer. 0.43. 